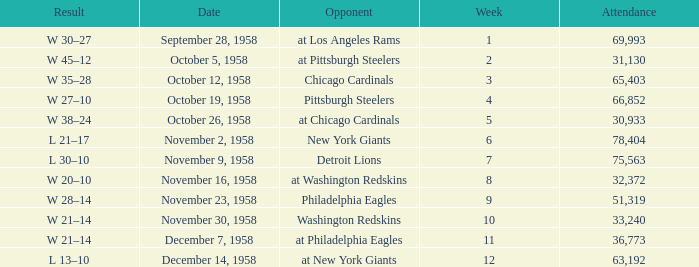What day had over 51,319 attending week 4? October 19, 1958. 